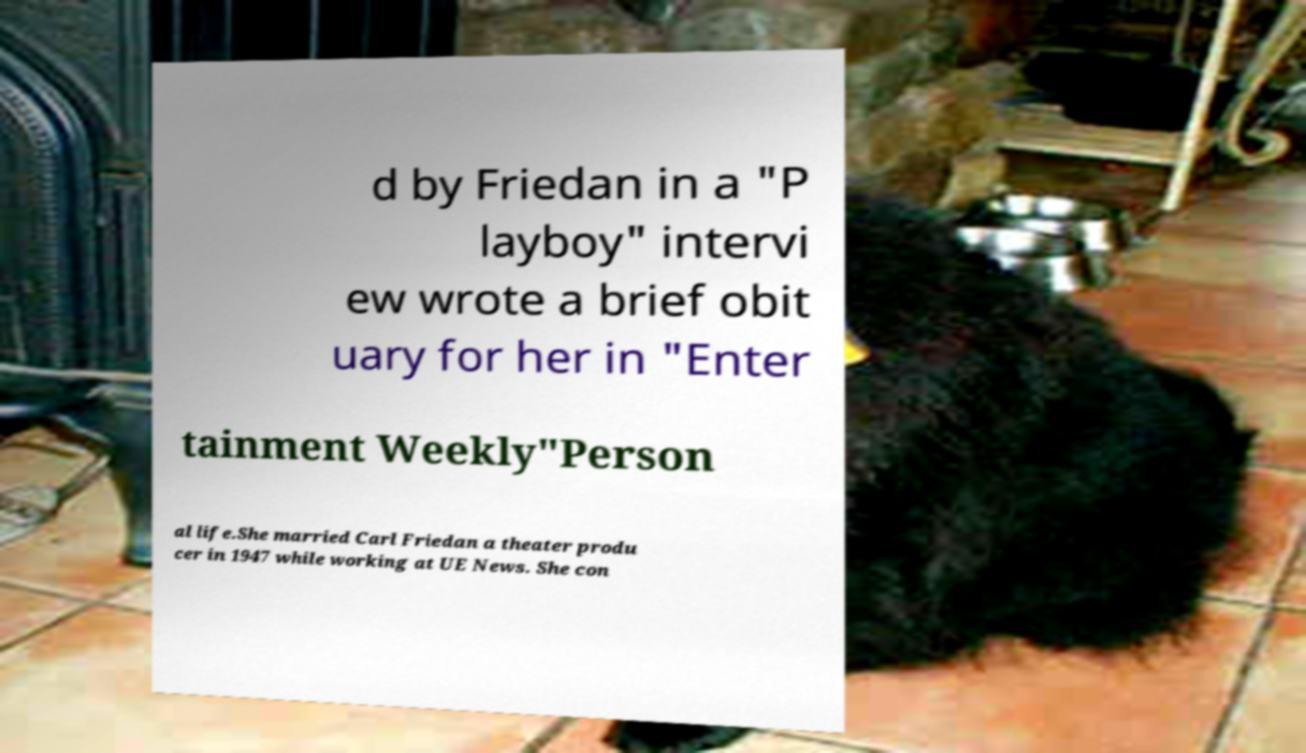Can you accurately transcribe the text from the provided image for me? d by Friedan in a "P layboy" intervi ew wrote a brief obit uary for her in "Enter tainment Weekly"Person al life.She married Carl Friedan a theater produ cer in 1947 while working at UE News. She con 